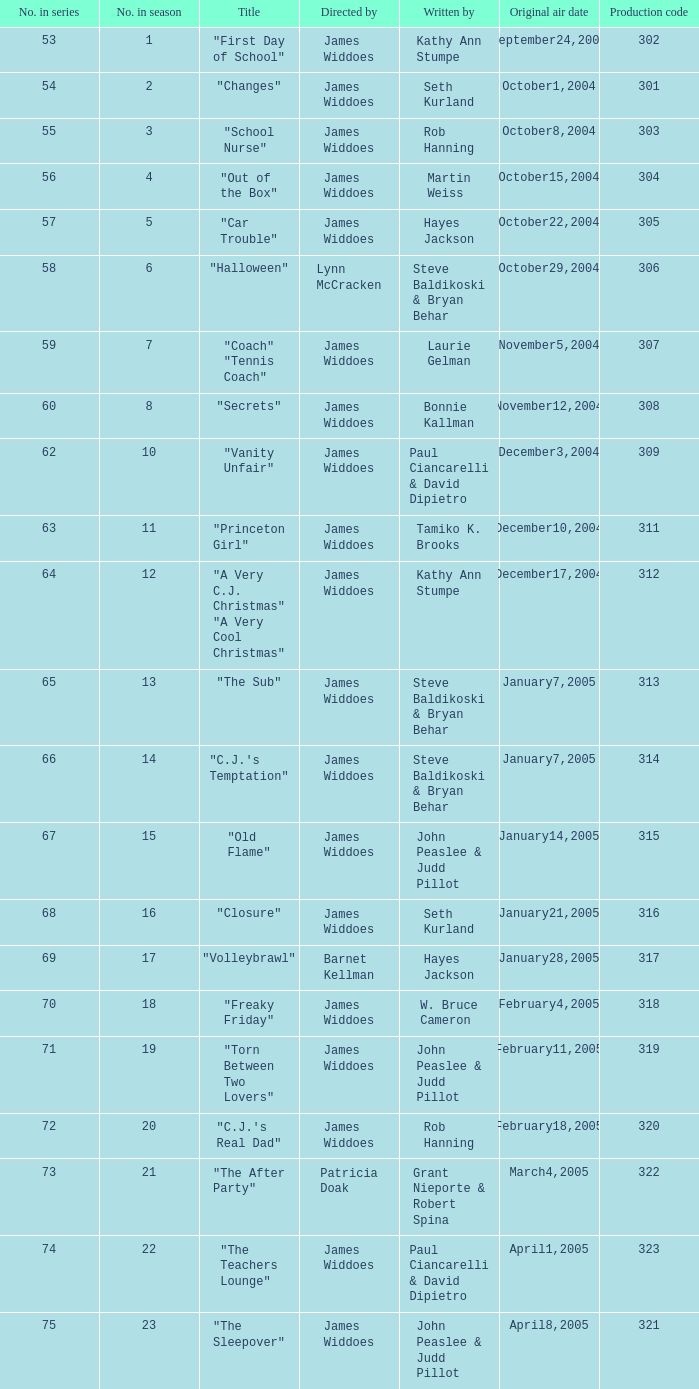How many production codes are there for "the sub"? 1.0. 